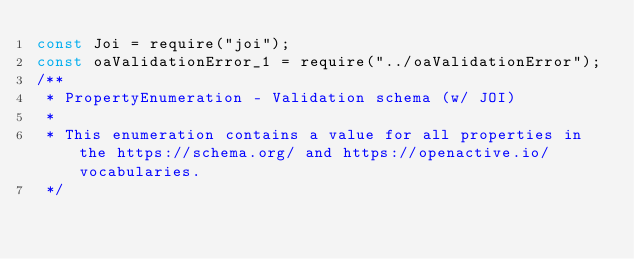<code> <loc_0><loc_0><loc_500><loc_500><_JavaScript_>const Joi = require("joi");
const oaValidationError_1 = require("../oaValidationError");
/**
 * PropertyEnumeration - Validation schema (w/ JOI)
 *
 * This enumeration contains a value for all properties in the https://schema.org/ and https://openactive.io/ vocabularies.
 */</code> 